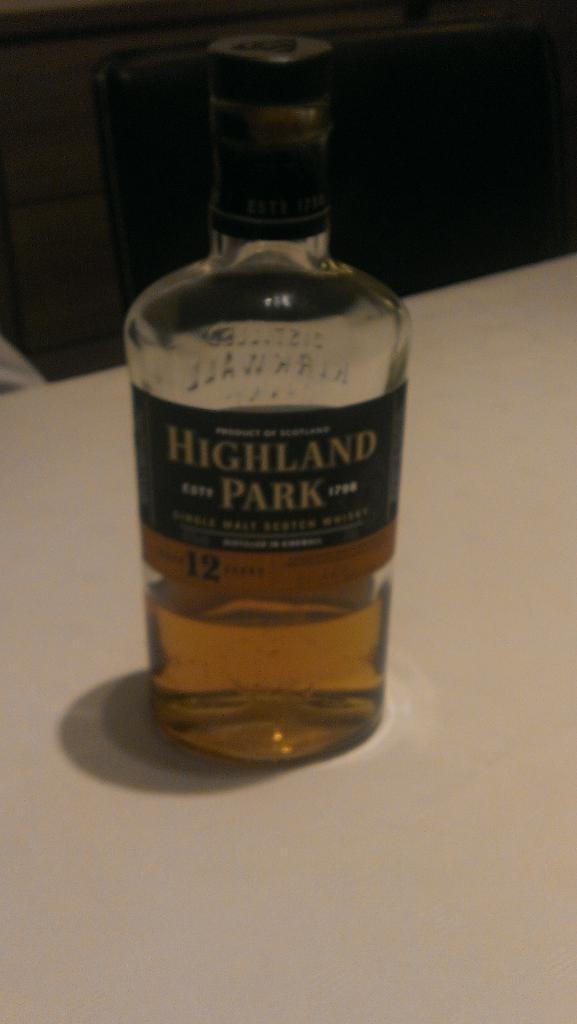Who makes that whisky?
Give a very brief answer. Highland park. What type of liquor is it?
Keep it short and to the point. Unanswerable. 